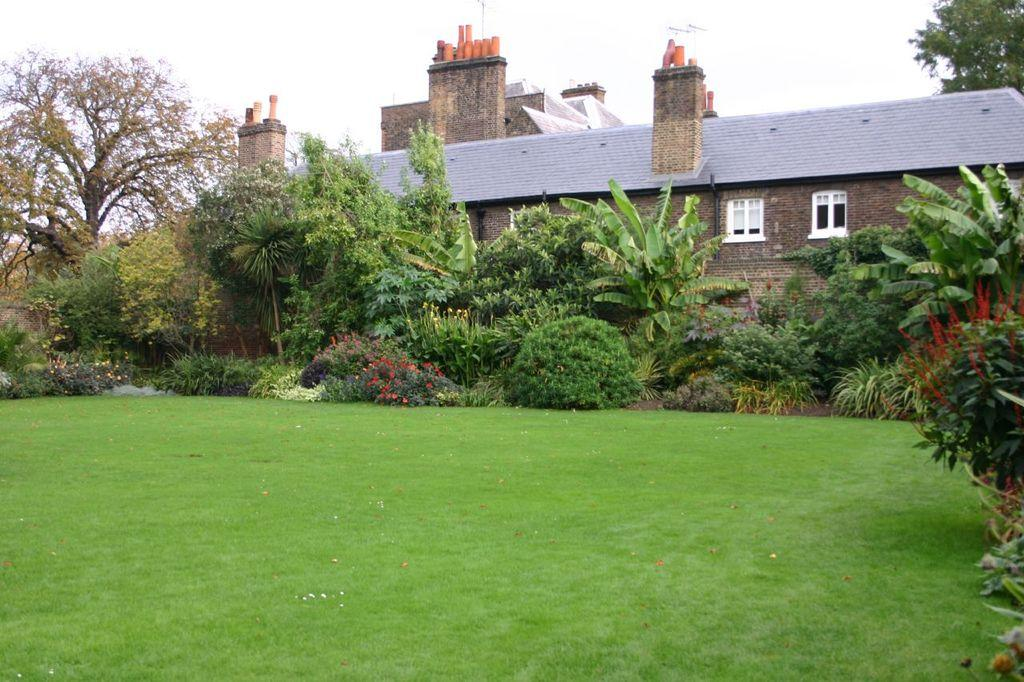What type of vegetation is visible in the image? There is grass in the image. What can be seen in the background of the image? There are trees and a house in the background of the image. What type of toothbrush is being used to clean the ants in the image? There are no toothbrushes or ants present in the image. 